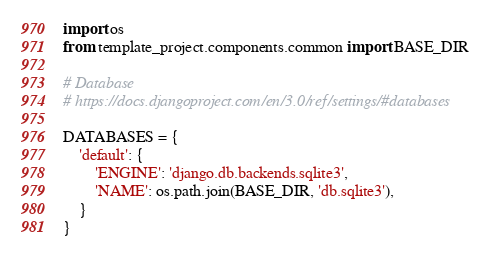Convert code to text. <code><loc_0><loc_0><loc_500><loc_500><_Python_>import os
from template_project.components.common import BASE_DIR

# Database
# https://docs.djangoproject.com/en/3.0/ref/settings/#databases

DATABASES = {
    'default': {
        'ENGINE': 'django.db.backends.sqlite3',
        'NAME': os.path.join(BASE_DIR, 'db.sqlite3'),
    }
}

</code> 